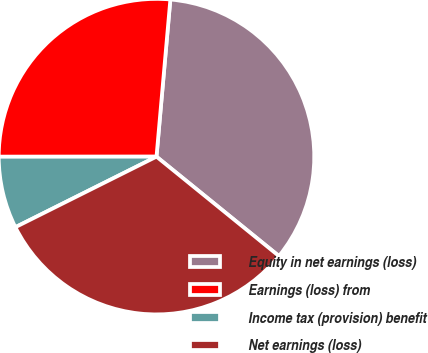<chart> <loc_0><loc_0><loc_500><loc_500><pie_chart><fcel>Equity in net earnings (loss)<fcel>Earnings (loss) from<fcel>Income tax (provision) benefit<fcel>Net earnings (loss)<nl><fcel>34.45%<fcel>26.41%<fcel>7.37%<fcel>31.77%<nl></chart> 